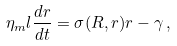Convert formula to latex. <formula><loc_0><loc_0><loc_500><loc_500>\eta _ { m } l \frac { d r } { d t } = \sigma ( R , r ) r - \gamma \, ,</formula> 